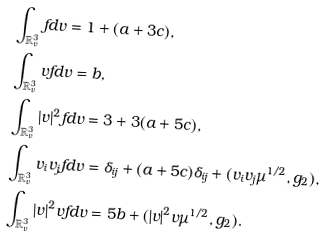<formula> <loc_0><loc_0><loc_500><loc_500>& \int _ { \mathbb { R } ^ { 3 } _ { v } } f d v = 1 + ( a + 3 c ) , \\ & \int _ { \mathbb { R } ^ { 3 } _ { v } } v f d v = b , \\ & \int _ { \mathbb { R } ^ { 3 } _ { v } } | v | ^ { 2 } f d v = 3 + 3 ( a + 5 c ) , \\ & \int _ { \mathbb { R } ^ { 3 } _ { v } } v _ { i } v _ { j } f d v = \delta _ { i j } + ( a + 5 c ) \delta _ { i j } + ( v _ { i } v _ { j } \mu ^ { 1 / 2 } , g _ { 2 } ) , \\ & \int _ { \mathbb { R } ^ { 3 } _ { v } } | v | ^ { 2 } v f d v = 5 b + ( | v | ^ { 2 } v \mu ^ { 1 / 2 } , g _ { 2 } ) .</formula> 